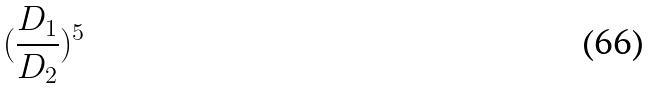Convert formula to latex. <formula><loc_0><loc_0><loc_500><loc_500>( \frac { D _ { 1 } } { D _ { 2 } } ) ^ { 5 }</formula> 